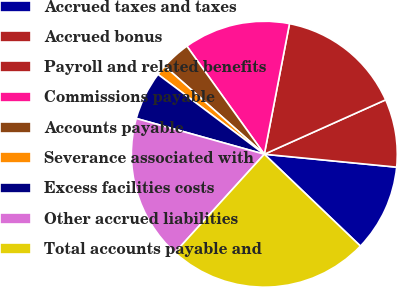<chart> <loc_0><loc_0><loc_500><loc_500><pie_chart><fcel>Accrued taxes and taxes<fcel>Accrued bonus<fcel>Payroll and related benefits<fcel>Commissions payable<fcel>Accounts payable<fcel>Severance associated with<fcel>Excess facilities costs<fcel>Other accrued liabilities<fcel>Total accounts payable and<nl><fcel>10.59%<fcel>8.26%<fcel>15.26%<fcel>12.93%<fcel>3.59%<fcel>1.26%<fcel>5.92%<fcel>17.59%<fcel>24.6%<nl></chart> 